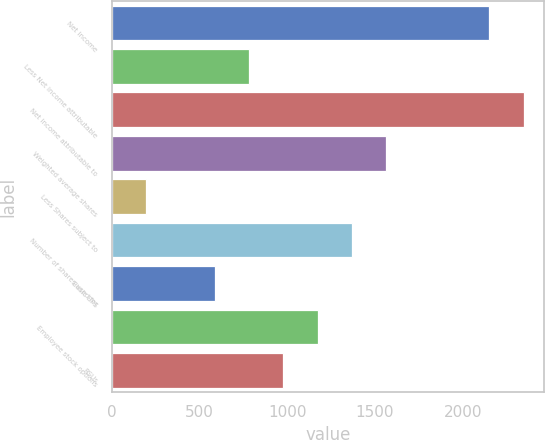Convert chart. <chart><loc_0><loc_0><loc_500><loc_500><bar_chart><fcel>Net income<fcel>Less Net income attributable<fcel>Net income attributable to<fcel>Weighted average shares<fcel>Less Shares subject to<fcel>Number of shares used for<fcel>Basic EPS<fcel>Employee stock options<fcel>RSUs<nl><fcel>2151.5<fcel>783<fcel>2347<fcel>1565<fcel>196.5<fcel>1369.5<fcel>587.5<fcel>1174<fcel>978.5<nl></chart> 